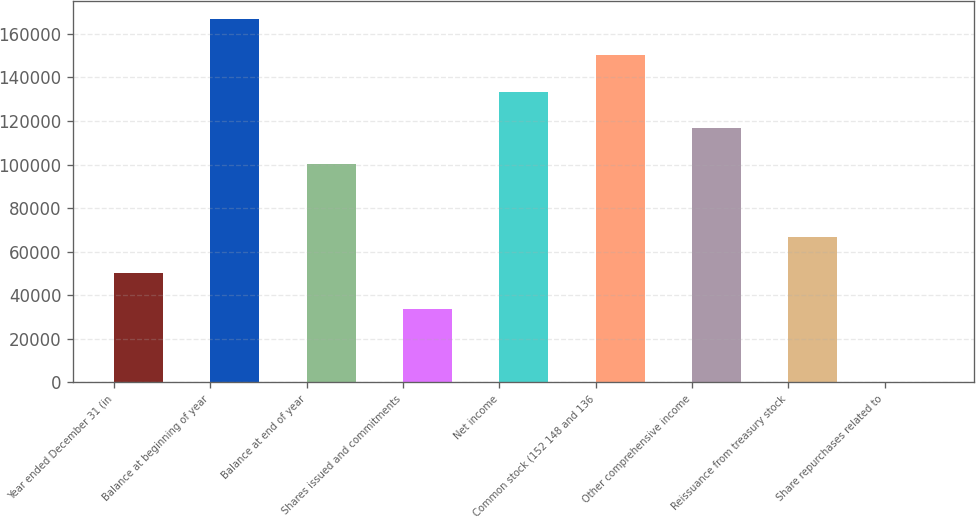Convert chart to OTSL. <chart><loc_0><loc_0><loc_500><loc_500><bar_chart><fcel>Year ended December 31 (in<fcel>Balance at beginning of year<fcel>Balance at end of year<fcel>Shares issued and commitments<fcel>Net income<fcel>Common stock (152 148 and 136<fcel>Other comprehensive income<fcel>Reissuance from treasury stock<fcel>Share repurchases related to<nl><fcel>50079.9<fcel>166884<fcel>100139<fcel>33393.6<fcel>133511<fcel>150198<fcel>116825<fcel>66766.2<fcel>21<nl></chart> 